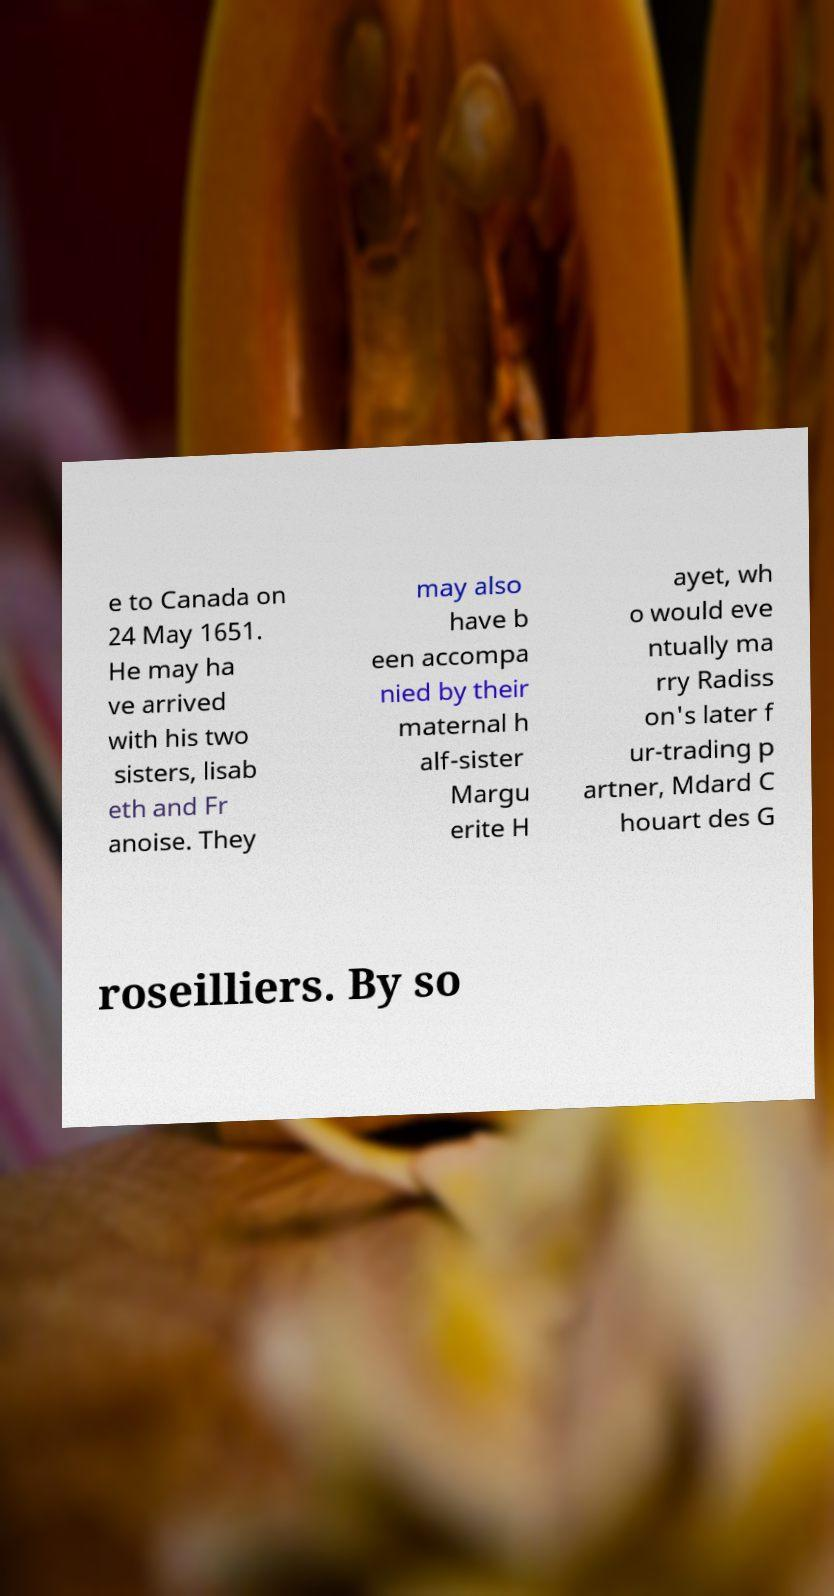I need the written content from this picture converted into text. Can you do that? e to Canada on 24 May 1651. He may ha ve arrived with his two sisters, lisab eth and Fr anoise. They may also have b een accompa nied by their maternal h alf-sister Margu erite H ayet, wh o would eve ntually ma rry Radiss on's later f ur-trading p artner, Mdard C houart des G roseilliers. By so 